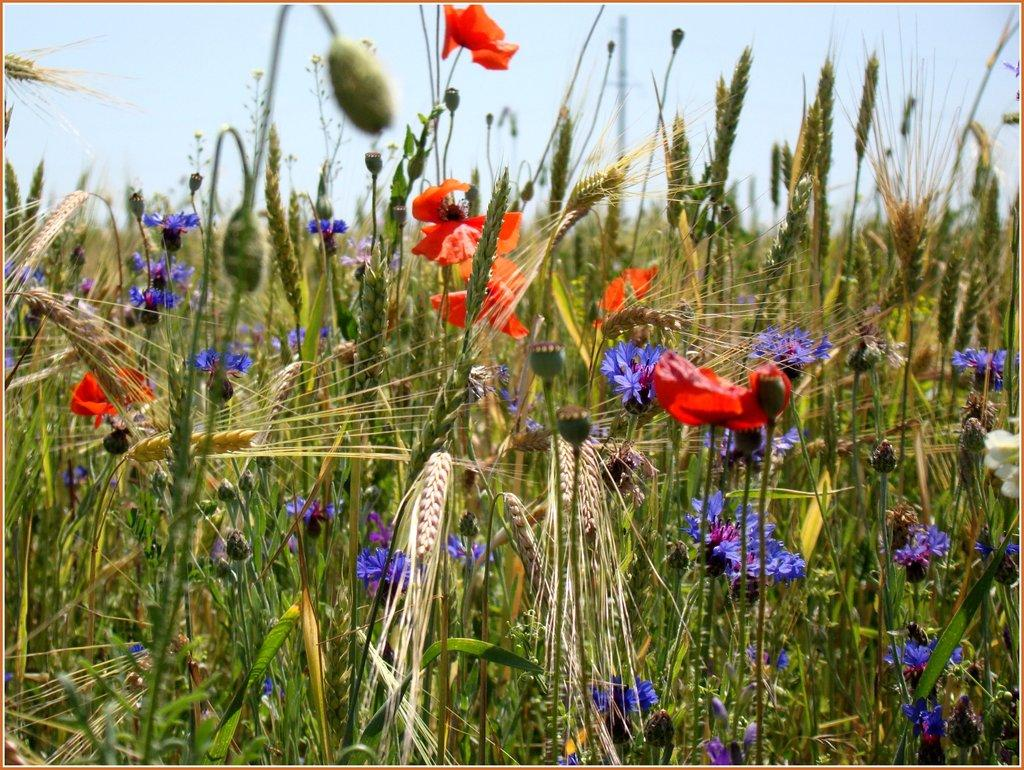What type of plants can be seen in the image? There are plants with flowers and plants with buds in the image. What can be seen behind the plants in the image? The sky is visible behind the plants in the image. What title is given to the person saying good-bye in the image? There is no person saying good-bye in the image, as it only features plants with flowers and buds against a sky background. 